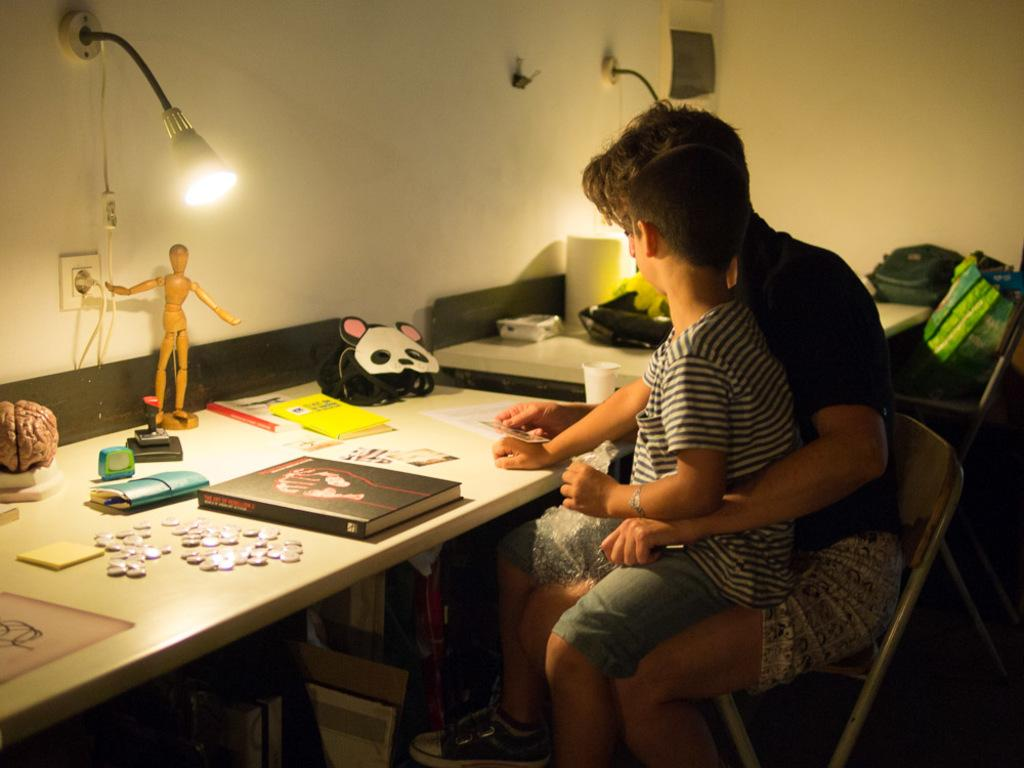Who is sitting in the image? There is a man and a boy sitting in the image. What is present in the image besides the people? There is a table, books, objects, a light, and a wall in the image. What is the purpose of the light in the image? The light above the table provides illumination for the people sitting there. What can be found on the table? There are books and other objects on the table. What type of veil is draped over the table in the image? There is no veil present in the image; it features a table with books and other objects. What kind of wine is being served at the table in the image? There is no wine present in the image; it features a table with books and other objects. 